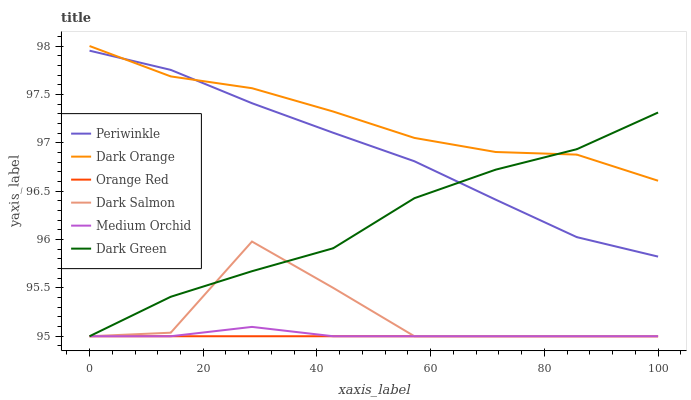Does Orange Red have the minimum area under the curve?
Answer yes or no. Yes. Does Dark Orange have the maximum area under the curve?
Answer yes or no. Yes. Does Medium Orchid have the minimum area under the curve?
Answer yes or no. No. Does Medium Orchid have the maximum area under the curve?
Answer yes or no. No. Is Orange Red the smoothest?
Answer yes or no. Yes. Is Dark Salmon the roughest?
Answer yes or no. Yes. Is Medium Orchid the smoothest?
Answer yes or no. No. Is Medium Orchid the roughest?
Answer yes or no. No. Does Medium Orchid have the lowest value?
Answer yes or no. Yes. Does Periwinkle have the lowest value?
Answer yes or no. No. Does Dark Orange have the highest value?
Answer yes or no. Yes. Does Medium Orchid have the highest value?
Answer yes or no. No. Is Dark Salmon less than Dark Orange?
Answer yes or no. Yes. Is Periwinkle greater than Orange Red?
Answer yes or no. Yes. Does Orange Red intersect Dark Salmon?
Answer yes or no. Yes. Is Orange Red less than Dark Salmon?
Answer yes or no. No. Is Orange Red greater than Dark Salmon?
Answer yes or no. No. Does Dark Salmon intersect Dark Orange?
Answer yes or no. No. 